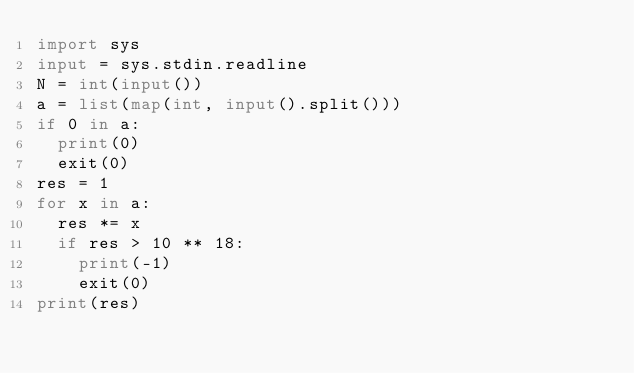<code> <loc_0><loc_0><loc_500><loc_500><_Python_>import sys
input = sys.stdin.readline
N = int(input())
a = list(map(int, input().split()))
if 0 in a:
  print(0)
  exit(0)
res = 1
for x in a:
  res *= x
  if res > 10 ** 18:
    print(-1)
    exit(0)
print(res)
</code> 